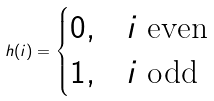Convert formula to latex. <formula><loc_0><loc_0><loc_500><loc_500>h ( i ) = \begin{cases} 0 , & i \text { even} \\ 1 , & i \text { odd} \end{cases}</formula> 